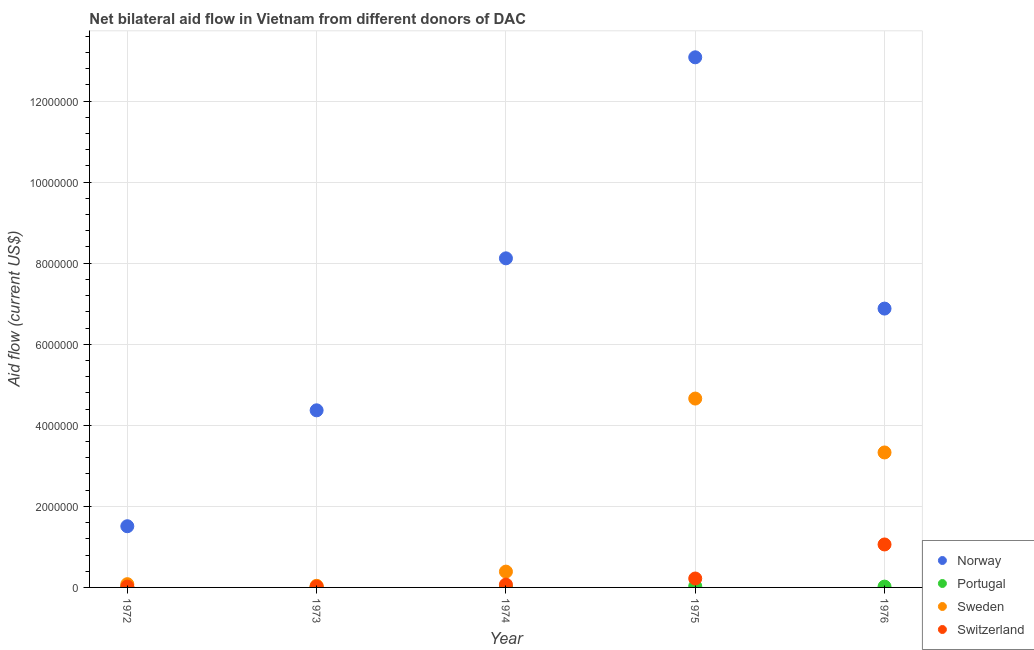Is the number of dotlines equal to the number of legend labels?
Give a very brief answer. Yes. What is the amount of aid given by norway in 1975?
Make the answer very short. 1.31e+07. Across all years, what is the maximum amount of aid given by switzerland?
Your answer should be compact. 1.06e+06. Across all years, what is the minimum amount of aid given by norway?
Your answer should be compact. 1.51e+06. In which year was the amount of aid given by portugal maximum?
Ensure brevity in your answer.  1975. What is the total amount of aid given by portugal in the graph?
Give a very brief answer. 8.00e+04. What is the difference between the amount of aid given by norway in 1972 and that in 1975?
Offer a very short reply. -1.16e+07. What is the difference between the amount of aid given by sweden in 1974 and the amount of aid given by portugal in 1976?
Ensure brevity in your answer.  3.70e+05. What is the average amount of aid given by sweden per year?
Your answer should be compact. 1.70e+06. In the year 1973, what is the difference between the amount of aid given by switzerland and amount of aid given by sweden?
Offer a terse response. -2.00e+04. In how many years, is the amount of aid given by portugal greater than 5600000 US$?
Your answer should be compact. 0. What is the ratio of the amount of aid given by switzerland in 1973 to that in 1976?
Provide a short and direct response. 0.02. Is the amount of aid given by sweden in 1974 less than that in 1975?
Give a very brief answer. Yes. Is the difference between the amount of aid given by sweden in 1973 and 1976 greater than the difference between the amount of aid given by norway in 1973 and 1976?
Your answer should be very brief. No. What is the difference between the highest and the second highest amount of aid given by norway?
Your response must be concise. 4.96e+06. What is the difference between the highest and the lowest amount of aid given by switzerland?
Provide a succinct answer. 1.04e+06. Is the sum of the amount of aid given by portugal in 1973 and 1976 greater than the maximum amount of aid given by sweden across all years?
Your answer should be compact. No. Is it the case that in every year, the sum of the amount of aid given by norway and amount of aid given by portugal is greater than the amount of aid given by sweden?
Your answer should be compact. Yes. Does the amount of aid given by portugal monotonically increase over the years?
Offer a terse response. No. What is the difference between two consecutive major ticks on the Y-axis?
Offer a very short reply. 2.00e+06. Are the values on the major ticks of Y-axis written in scientific E-notation?
Offer a very short reply. No. Does the graph contain any zero values?
Ensure brevity in your answer.  No. Does the graph contain grids?
Offer a very short reply. Yes. How many legend labels are there?
Keep it short and to the point. 4. What is the title of the graph?
Offer a very short reply. Net bilateral aid flow in Vietnam from different donors of DAC. Does "International Development Association" appear as one of the legend labels in the graph?
Provide a short and direct response. No. What is the Aid flow (current US$) of Norway in 1972?
Make the answer very short. 1.51e+06. What is the Aid flow (current US$) in Portugal in 1972?
Ensure brevity in your answer.  10000. What is the Aid flow (current US$) of Switzerland in 1972?
Offer a very short reply. 2.00e+04. What is the Aid flow (current US$) in Norway in 1973?
Give a very brief answer. 4.37e+06. What is the Aid flow (current US$) in Sweden in 1973?
Make the answer very short. 4.00e+04. What is the Aid flow (current US$) in Norway in 1974?
Your response must be concise. 8.12e+06. What is the Aid flow (current US$) in Portugal in 1974?
Ensure brevity in your answer.  10000. What is the Aid flow (current US$) of Switzerland in 1974?
Your answer should be very brief. 7.00e+04. What is the Aid flow (current US$) of Norway in 1975?
Your response must be concise. 1.31e+07. What is the Aid flow (current US$) in Portugal in 1975?
Make the answer very short. 3.00e+04. What is the Aid flow (current US$) of Sweden in 1975?
Provide a short and direct response. 4.66e+06. What is the Aid flow (current US$) in Switzerland in 1975?
Your response must be concise. 2.20e+05. What is the Aid flow (current US$) in Norway in 1976?
Provide a short and direct response. 6.88e+06. What is the Aid flow (current US$) in Portugal in 1976?
Your answer should be very brief. 2.00e+04. What is the Aid flow (current US$) of Sweden in 1976?
Your response must be concise. 3.33e+06. What is the Aid flow (current US$) in Switzerland in 1976?
Keep it short and to the point. 1.06e+06. Across all years, what is the maximum Aid flow (current US$) of Norway?
Your answer should be compact. 1.31e+07. Across all years, what is the maximum Aid flow (current US$) in Portugal?
Ensure brevity in your answer.  3.00e+04. Across all years, what is the maximum Aid flow (current US$) of Sweden?
Ensure brevity in your answer.  4.66e+06. Across all years, what is the maximum Aid flow (current US$) in Switzerland?
Give a very brief answer. 1.06e+06. Across all years, what is the minimum Aid flow (current US$) in Norway?
Ensure brevity in your answer.  1.51e+06. Across all years, what is the minimum Aid flow (current US$) in Switzerland?
Make the answer very short. 2.00e+04. What is the total Aid flow (current US$) of Norway in the graph?
Provide a short and direct response. 3.40e+07. What is the total Aid flow (current US$) of Portugal in the graph?
Your response must be concise. 8.00e+04. What is the total Aid flow (current US$) in Sweden in the graph?
Make the answer very short. 8.50e+06. What is the total Aid flow (current US$) in Switzerland in the graph?
Provide a succinct answer. 1.39e+06. What is the difference between the Aid flow (current US$) in Norway in 1972 and that in 1973?
Give a very brief answer. -2.86e+06. What is the difference between the Aid flow (current US$) of Portugal in 1972 and that in 1973?
Give a very brief answer. 0. What is the difference between the Aid flow (current US$) of Norway in 1972 and that in 1974?
Provide a short and direct response. -6.61e+06. What is the difference between the Aid flow (current US$) of Portugal in 1972 and that in 1974?
Offer a very short reply. 0. What is the difference between the Aid flow (current US$) in Sweden in 1972 and that in 1974?
Provide a succinct answer. -3.10e+05. What is the difference between the Aid flow (current US$) of Norway in 1972 and that in 1975?
Provide a short and direct response. -1.16e+07. What is the difference between the Aid flow (current US$) in Sweden in 1972 and that in 1975?
Give a very brief answer. -4.58e+06. What is the difference between the Aid flow (current US$) of Switzerland in 1972 and that in 1975?
Your response must be concise. -2.00e+05. What is the difference between the Aid flow (current US$) of Norway in 1972 and that in 1976?
Offer a very short reply. -5.37e+06. What is the difference between the Aid flow (current US$) of Sweden in 1972 and that in 1976?
Your response must be concise. -3.25e+06. What is the difference between the Aid flow (current US$) of Switzerland in 1972 and that in 1976?
Ensure brevity in your answer.  -1.04e+06. What is the difference between the Aid flow (current US$) in Norway in 1973 and that in 1974?
Offer a very short reply. -3.75e+06. What is the difference between the Aid flow (current US$) of Sweden in 1973 and that in 1974?
Offer a terse response. -3.50e+05. What is the difference between the Aid flow (current US$) in Norway in 1973 and that in 1975?
Make the answer very short. -8.71e+06. What is the difference between the Aid flow (current US$) of Portugal in 1973 and that in 1975?
Offer a very short reply. -2.00e+04. What is the difference between the Aid flow (current US$) of Sweden in 1973 and that in 1975?
Your response must be concise. -4.62e+06. What is the difference between the Aid flow (current US$) in Switzerland in 1973 and that in 1975?
Your answer should be very brief. -2.00e+05. What is the difference between the Aid flow (current US$) of Norway in 1973 and that in 1976?
Offer a very short reply. -2.51e+06. What is the difference between the Aid flow (current US$) in Sweden in 1973 and that in 1976?
Offer a terse response. -3.29e+06. What is the difference between the Aid flow (current US$) of Switzerland in 1973 and that in 1976?
Keep it short and to the point. -1.04e+06. What is the difference between the Aid flow (current US$) in Norway in 1974 and that in 1975?
Give a very brief answer. -4.96e+06. What is the difference between the Aid flow (current US$) of Sweden in 1974 and that in 1975?
Your response must be concise. -4.27e+06. What is the difference between the Aid flow (current US$) of Norway in 1974 and that in 1976?
Your answer should be compact. 1.24e+06. What is the difference between the Aid flow (current US$) of Sweden in 1974 and that in 1976?
Make the answer very short. -2.94e+06. What is the difference between the Aid flow (current US$) of Switzerland in 1974 and that in 1976?
Offer a very short reply. -9.90e+05. What is the difference between the Aid flow (current US$) of Norway in 1975 and that in 1976?
Offer a terse response. 6.20e+06. What is the difference between the Aid flow (current US$) in Portugal in 1975 and that in 1976?
Offer a very short reply. 10000. What is the difference between the Aid flow (current US$) of Sweden in 1975 and that in 1976?
Offer a terse response. 1.33e+06. What is the difference between the Aid flow (current US$) of Switzerland in 1975 and that in 1976?
Offer a terse response. -8.40e+05. What is the difference between the Aid flow (current US$) in Norway in 1972 and the Aid flow (current US$) in Portugal in 1973?
Ensure brevity in your answer.  1.50e+06. What is the difference between the Aid flow (current US$) of Norway in 1972 and the Aid flow (current US$) of Sweden in 1973?
Keep it short and to the point. 1.47e+06. What is the difference between the Aid flow (current US$) in Norway in 1972 and the Aid flow (current US$) in Switzerland in 1973?
Give a very brief answer. 1.49e+06. What is the difference between the Aid flow (current US$) in Norway in 1972 and the Aid flow (current US$) in Portugal in 1974?
Your answer should be very brief. 1.50e+06. What is the difference between the Aid flow (current US$) of Norway in 1972 and the Aid flow (current US$) of Sweden in 1974?
Offer a very short reply. 1.12e+06. What is the difference between the Aid flow (current US$) of Norway in 1972 and the Aid flow (current US$) of Switzerland in 1974?
Offer a terse response. 1.44e+06. What is the difference between the Aid flow (current US$) of Portugal in 1972 and the Aid flow (current US$) of Sweden in 1974?
Provide a succinct answer. -3.80e+05. What is the difference between the Aid flow (current US$) of Portugal in 1972 and the Aid flow (current US$) of Switzerland in 1974?
Make the answer very short. -6.00e+04. What is the difference between the Aid flow (current US$) of Norway in 1972 and the Aid flow (current US$) of Portugal in 1975?
Provide a short and direct response. 1.48e+06. What is the difference between the Aid flow (current US$) in Norway in 1972 and the Aid flow (current US$) in Sweden in 1975?
Provide a succinct answer. -3.15e+06. What is the difference between the Aid flow (current US$) of Norway in 1972 and the Aid flow (current US$) of Switzerland in 1975?
Ensure brevity in your answer.  1.29e+06. What is the difference between the Aid flow (current US$) in Portugal in 1972 and the Aid flow (current US$) in Sweden in 1975?
Your answer should be compact. -4.65e+06. What is the difference between the Aid flow (current US$) of Portugal in 1972 and the Aid flow (current US$) of Switzerland in 1975?
Ensure brevity in your answer.  -2.10e+05. What is the difference between the Aid flow (current US$) of Sweden in 1972 and the Aid flow (current US$) of Switzerland in 1975?
Your response must be concise. -1.40e+05. What is the difference between the Aid flow (current US$) of Norway in 1972 and the Aid flow (current US$) of Portugal in 1976?
Make the answer very short. 1.49e+06. What is the difference between the Aid flow (current US$) of Norway in 1972 and the Aid flow (current US$) of Sweden in 1976?
Keep it short and to the point. -1.82e+06. What is the difference between the Aid flow (current US$) in Norway in 1972 and the Aid flow (current US$) in Switzerland in 1976?
Keep it short and to the point. 4.50e+05. What is the difference between the Aid flow (current US$) in Portugal in 1972 and the Aid flow (current US$) in Sweden in 1976?
Give a very brief answer. -3.32e+06. What is the difference between the Aid flow (current US$) of Portugal in 1972 and the Aid flow (current US$) of Switzerland in 1976?
Your response must be concise. -1.05e+06. What is the difference between the Aid flow (current US$) of Sweden in 1972 and the Aid flow (current US$) of Switzerland in 1976?
Keep it short and to the point. -9.80e+05. What is the difference between the Aid flow (current US$) of Norway in 1973 and the Aid flow (current US$) of Portugal in 1974?
Offer a very short reply. 4.36e+06. What is the difference between the Aid flow (current US$) in Norway in 1973 and the Aid flow (current US$) in Sweden in 1974?
Offer a terse response. 3.98e+06. What is the difference between the Aid flow (current US$) of Norway in 1973 and the Aid flow (current US$) of Switzerland in 1974?
Give a very brief answer. 4.30e+06. What is the difference between the Aid flow (current US$) in Portugal in 1973 and the Aid flow (current US$) in Sweden in 1974?
Keep it short and to the point. -3.80e+05. What is the difference between the Aid flow (current US$) of Portugal in 1973 and the Aid flow (current US$) of Switzerland in 1974?
Your answer should be compact. -6.00e+04. What is the difference between the Aid flow (current US$) of Sweden in 1973 and the Aid flow (current US$) of Switzerland in 1974?
Offer a terse response. -3.00e+04. What is the difference between the Aid flow (current US$) of Norway in 1973 and the Aid flow (current US$) of Portugal in 1975?
Make the answer very short. 4.34e+06. What is the difference between the Aid flow (current US$) in Norway in 1973 and the Aid flow (current US$) in Switzerland in 1975?
Offer a terse response. 4.15e+06. What is the difference between the Aid flow (current US$) in Portugal in 1973 and the Aid flow (current US$) in Sweden in 1975?
Your answer should be compact. -4.65e+06. What is the difference between the Aid flow (current US$) of Portugal in 1973 and the Aid flow (current US$) of Switzerland in 1975?
Offer a very short reply. -2.10e+05. What is the difference between the Aid flow (current US$) in Norway in 1973 and the Aid flow (current US$) in Portugal in 1976?
Your response must be concise. 4.35e+06. What is the difference between the Aid flow (current US$) of Norway in 1973 and the Aid flow (current US$) of Sweden in 1976?
Make the answer very short. 1.04e+06. What is the difference between the Aid flow (current US$) in Norway in 1973 and the Aid flow (current US$) in Switzerland in 1976?
Provide a succinct answer. 3.31e+06. What is the difference between the Aid flow (current US$) of Portugal in 1973 and the Aid flow (current US$) of Sweden in 1976?
Provide a succinct answer. -3.32e+06. What is the difference between the Aid flow (current US$) in Portugal in 1973 and the Aid flow (current US$) in Switzerland in 1976?
Provide a short and direct response. -1.05e+06. What is the difference between the Aid flow (current US$) in Sweden in 1973 and the Aid flow (current US$) in Switzerland in 1976?
Ensure brevity in your answer.  -1.02e+06. What is the difference between the Aid flow (current US$) in Norway in 1974 and the Aid flow (current US$) in Portugal in 1975?
Ensure brevity in your answer.  8.09e+06. What is the difference between the Aid flow (current US$) in Norway in 1974 and the Aid flow (current US$) in Sweden in 1975?
Ensure brevity in your answer.  3.46e+06. What is the difference between the Aid flow (current US$) of Norway in 1974 and the Aid flow (current US$) of Switzerland in 1975?
Your response must be concise. 7.90e+06. What is the difference between the Aid flow (current US$) of Portugal in 1974 and the Aid flow (current US$) of Sweden in 1975?
Offer a terse response. -4.65e+06. What is the difference between the Aid flow (current US$) in Portugal in 1974 and the Aid flow (current US$) in Switzerland in 1975?
Offer a terse response. -2.10e+05. What is the difference between the Aid flow (current US$) of Sweden in 1974 and the Aid flow (current US$) of Switzerland in 1975?
Offer a terse response. 1.70e+05. What is the difference between the Aid flow (current US$) in Norway in 1974 and the Aid flow (current US$) in Portugal in 1976?
Give a very brief answer. 8.10e+06. What is the difference between the Aid flow (current US$) in Norway in 1974 and the Aid flow (current US$) in Sweden in 1976?
Your answer should be very brief. 4.79e+06. What is the difference between the Aid flow (current US$) in Norway in 1974 and the Aid flow (current US$) in Switzerland in 1976?
Offer a terse response. 7.06e+06. What is the difference between the Aid flow (current US$) in Portugal in 1974 and the Aid flow (current US$) in Sweden in 1976?
Offer a very short reply. -3.32e+06. What is the difference between the Aid flow (current US$) in Portugal in 1974 and the Aid flow (current US$) in Switzerland in 1976?
Your answer should be very brief. -1.05e+06. What is the difference between the Aid flow (current US$) of Sweden in 1974 and the Aid flow (current US$) of Switzerland in 1976?
Make the answer very short. -6.70e+05. What is the difference between the Aid flow (current US$) in Norway in 1975 and the Aid flow (current US$) in Portugal in 1976?
Offer a terse response. 1.31e+07. What is the difference between the Aid flow (current US$) in Norway in 1975 and the Aid flow (current US$) in Sweden in 1976?
Offer a very short reply. 9.75e+06. What is the difference between the Aid flow (current US$) of Norway in 1975 and the Aid flow (current US$) of Switzerland in 1976?
Make the answer very short. 1.20e+07. What is the difference between the Aid flow (current US$) of Portugal in 1975 and the Aid flow (current US$) of Sweden in 1976?
Your response must be concise. -3.30e+06. What is the difference between the Aid flow (current US$) of Portugal in 1975 and the Aid flow (current US$) of Switzerland in 1976?
Ensure brevity in your answer.  -1.03e+06. What is the difference between the Aid flow (current US$) in Sweden in 1975 and the Aid flow (current US$) in Switzerland in 1976?
Your answer should be compact. 3.60e+06. What is the average Aid flow (current US$) of Norway per year?
Offer a terse response. 6.79e+06. What is the average Aid flow (current US$) of Portugal per year?
Your answer should be very brief. 1.60e+04. What is the average Aid flow (current US$) of Sweden per year?
Give a very brief answer. 1.70e+06. What is the average Aid flow (current US$) of Switzerland per year?
Your response must be concise. 2.78e+05. In the year 1972, what is the difference between the Aid flow (current US$) of Norway and Aid flow (current US$) of Portugal?
Provide a succinct answer. 1.50e+06. In the year 1972, what is the difference between the Aid flow (current US$) in Norway and Aid flow (current US$) in Sweden?
Keep it short and to the point. 1.43e+06. In the year 1972, what is the difference between the Aid flow (current US$) in Norway and Aid flow (current US$) in Switzerland?
Offer a very short reply. 1.49e+06. In the year 1972, what is the difference between the Aid flow (current US$) of Portugal and Aid flow (current US$) of Sweden?
Offer a terse response. -7.00e+04. In the year 1972, what is the difference between the Aid flow (current US$) in Sweden and Aid flow (current US$) in Switzerland?
Ensure brevity in your answer.  6.00e+04. In the year 1973, what is the difference between the Aid flow (current US$) of Norway and Aid flow (current US$) of Portugal?
Your answer should be compact. 4.36e+06. In the year 1973, what is the difference between the Aid flow (current US$) in Norway and Aid flow (current US$) in Sweden?
Your answer should be compact. 4.33e+06. In the year 1973, what is the difference between the Aid flow (current US$) in Norway and Aid flow (current US$) in Switzerland?
Give a very brief answer. 4.35e+06. In the year 1974, what is the difference between the Aid flow (current US$) in Norway and Aid flow (current US$) in Portugal?
Give a very brief answer. 8.11e+06. In the year 1974, what is the difference between the Aid flow (current US$) in Norway and Aid flow (current US$) in Sweden?
Your answer should be compact. 7.73e+06. In the year 1974, what is the difference between the Aid flow (current US$) in Norway and Aid flow (current US$) in Switzerland?
Your answer should be compact. 8.05e+06. In the year 1974, what is the difference between the Aid flow (current US$) of Portugal and Aid flow (current US$) of Sweden?
Ensure brevity in your answer.  -3.80e+05. In the year 1974, what is the difference between the Aid flow (current US$) in Portugal and Aid flow (current US$) in Switzerland?
Give a very brief answer. -6.00e+04. In the year 1975, what is the difference between the Aid flow (current US$) in Norway and Aid flow (current US$) in Portugal?
Your answer should be very brief. 1.30e+07. In the year 1975, what is the difference between the Aid flow (current US$) in Norway and Aid flow (current US$) in Sweden?
Your response must be concise. 8.42e+06. In the year 1975, what is the difference between the Aid flow (current US$) in Norway and Aid flow (current US$) in Switzerland?
Provide a succinct answer. 1.29e+07. In the year 1975, what is the difference between the Aid flow (current US$) of Portugal and Aid flow (current US$) of Sweden?
Provide a succinct answer. -4.63e+06. In the year 1975, what is the difference between the Aid flow (current US$) in Sweden and Aid flow (current US$) in Switzerland?
Your answer should be very brief. 4.44e+06. In the year 1976, what is the difference between the Aid flow (current US$) in Norway and Aid flow (current US$) in Portugal?
Your response must be concise. 6.86e+06. In the year 1976, what is the difference between the Aid flow (current US$) of Norway and Aid flow (current US$) of Sweden?
Give a very brief answer. 3.55e+06. In the year 1976, what is the difference between the Aid flow (current US$) in Norway and Aid flow (current US$) in Switzerland?
Your answer should be very brief. 5.82e+06. In the year 1976, what is the difference between the Aid flow (current US$) of Portugal and Aid flow (current US$) of Sweden?
Your answer should be very brief. -3.31e+06. In the year 1976, what is the difference between the Aid flow (current US$) of Portugal and Aid flow (current US$) of Switzerland?
Provide a short and direct response. -1.04e+06. In the year 1976, what is the difference between the Aid flow (current US$) in Sweden and Aid flow (current US$) in Switzerland?
Keep it short and to the point. 2.27e+06. What is the ratio of the Aid flow (current US$) of Norway in 1972 to that in 1973?
Keep it short and to the point. 0.35. What is the ratio of the Aid flow (current US$) in Portugal in 1972 to that in 1973?
Your answer should be compact. 1. What is the ratio of the Aid flow (current US$) of Norway in 1972 to that in 1974?
Your answer should be very brief. 0.19. What is the ratio of the Aid flow (current US$) in Sweden in 1972 to that in 1974?
Keep it short and to the point. 0.21. What is the ratio of the Aid flow (current US$) of Switzerland in 1972 to that in 1974?
Offer a terse response. 0.29. What is the ratio of the Aid flow (current US$) in Norway in 1972 to that in 1975?
Your answer should be compact. 0.12. What is the ratio of the Aid flow (current US$) of Portugal in 1972 to that in 1975?
Give a very brief answer. 0.33. What is the ratio of the Aid flow (current US$) in Sweden in 1972 to that in 1975?
Your answer should be compact. 0.02. What is the ratio of the Aid flow (current US$) of Switzerland in 1972 to that in 1975?
Offer a very short reply. 0.09. What is the ratio of the Aid flow (current US$) of Norway in 1972 to that in 1976?
Give a very brief answer. 0.22. What is the ratio of the Aid flow (current US$) of Portugal in 1972 to that in 1976?
Make the answer very short. 0.5. What is the ratio of the Aid flow (current US$) of Sweden in 1972 to that in 1976?
Make the answer very short. 0.02. What is the ratio of the Aid flow (current US$) in Switzerland in 1972 to that in 1976?
Provide a succinct answer. 0.02. What is the ratio of the Aid flow (current US$) of Norway in 1973 to that in 1974?
Your answer should be very brief. 0.54. What is the ratio of the Aid flow (current US$) in Sweden in 1973 to that in 1974?
Your response must be concise. 0.1. What is the ratio of the Aid flow (current US$) of Switzerland in 1973 to that in 1974?
Offer a very short reply. 0.29. What is the ratio of the Aid flow (current US$) in Norway in 1973 to that in 1975?
Your response must be concise. 0.33. What is the ratio of the Aid flow (current US$) in Portugal in 1973 to that in 1975?
Provide a succinct answer. 0.33. What is the ratio of the Aid flow (current US$) in Sweden in 1973 to that in 1975?
Ensure brevity in your answer.  0.01. What is the ratio of the Aid flow (current US$) of Switzerland in 1973 to that in 1975?
Keep it short and to the point. 0.09. What is the ratio of the Aid flow (current US$) of Norway in 1973 to that in 1976?
Offer a very short reply. 0.64. What is the ratio of the Aid flow (current US$) of Portugal in 1973 to that in 1976?
Your response must be concise. 0.5. What is the ratio of the Aid flow (current US$) of Sweden in 1973 to that in 1976?
Provide a short and direct response. 0.01. What is the ratio of the Aid flow (current US$) in Switzerland in 1973 to that in 1976?
Give a very brief answer. 0.02. What is the ratio of the Aid flow (current US$) in Norway in 1974 to that in 1975?
Provide a succinct answer. 0.62. What is the ratio of the Aid flow (current US$) of Sweden in 1974 to that in 1975?
Keep it short and to the point. 0.08. What is the ratio of the Aid flow (current US$) in Switzerland in 1974 to that in 1975?
Provide a short and direct response. 0.32. What is the ratio of the Aid flow (current US$) in Norway in 1974 to that in 1976?
Keep it short and to the point. 1.18. What is the ratio of the Aid flow (current US$) in Portugal in 1974 to that in 1976?
Keep it short and to the point. 0.5. What is the ratio of the Aid flow (current US$) in Sweden in 1974 to that in 1976?
Make the answer very short. 0.12. What is the ratio of the Aid flow (current US$) in Switzerland in 1974 to that in 1976?
Your answer should be very brief. 0.07. What is the ratio of the Aid flow (current US$) of Norway in 1975 to that in 1976?
Provide a short and direct response. 1.9. What is the ratio of the Aid flow (current US$) in Sweden in 1975 to that in 1976?
Offer a very short reply. 1.4. What is the ratio of the Aid flow (current US$) in Switzerland in 1975 to that in 1976?
Your answer should be very brief. 0.21. What is the difference between the highest and the second highest Aid flow (current US$) in Norway?
Give a very brief answer. 4.96e+06. What is the difference between the highest and the second highest Aid flow (current US$) of Portugal?
Your answer should be compact. 10000. What is the difference between the highest and the second highest Aid flow (current US$) of Sweden?
Provide a succinct answer. 1.33e+06. What is the difference between the highest and the second highest Aid flow (current US$) of Switzerland?
Provide a succinct answer. 8.40e+05. What is the difference between the highest and the lowest Aid flow (current US$) of Norway?
Ensure brevity in your answer.  1.16e+07. What is the difference between the highest and the lowest Aid flow (current US$) of Portugal?
Ensure brevity in your answer.  2.00e+04. What is the difference between the highest and the lowest Aid flow (current US$) in Sweden?
Provide a short and direct response. 4.62e+06. What is the difference between the highest and the lowest Aid flow (current US$) of Switzerland?
Your answer should be very brief. 1.04e+06. 